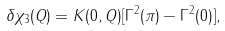Convert formula to latex. <formula><loc_0><loc_0><loc_500><loc_500>\delta \chi _ { 3 } ( Q ) = K ( 0 , Q ) [ \Gamma ^ { 2 } ( \pi ) - \Gamma ^ { 2 } ( 0 ) ] ,</formula> 